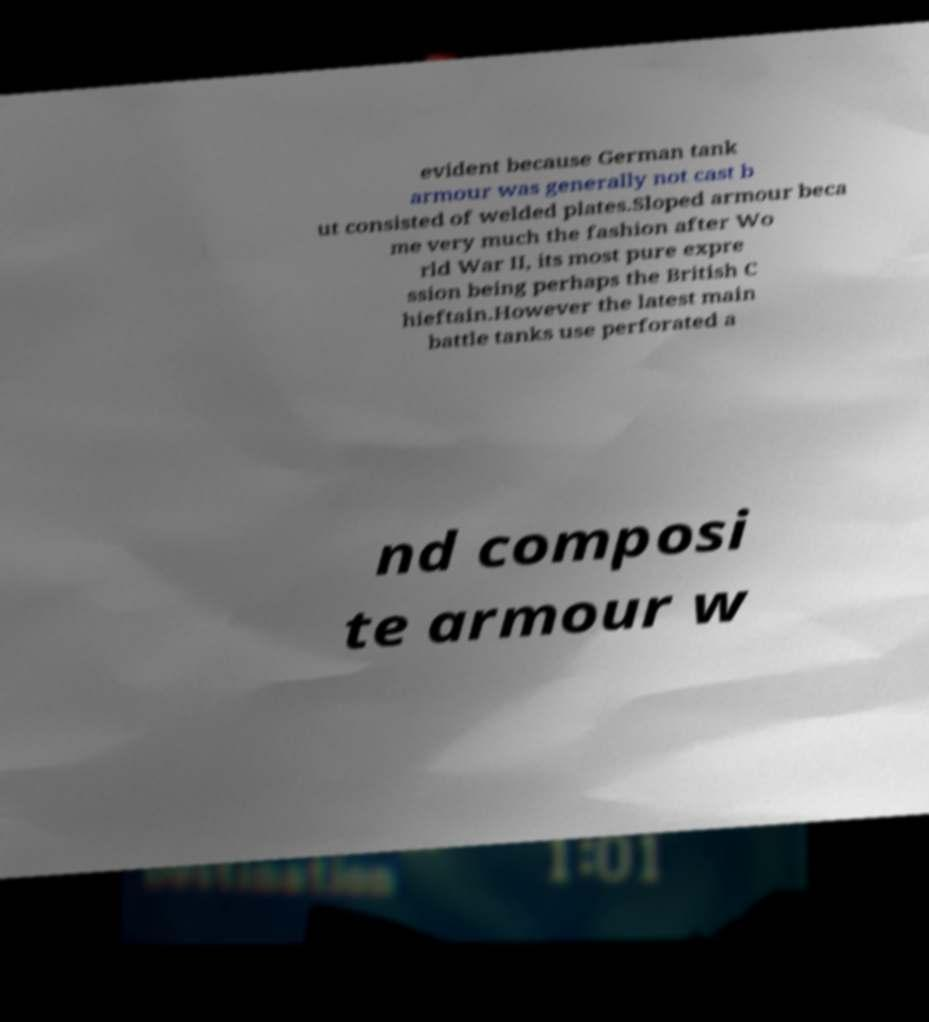For documentation purposes, I need the text within this image transcribed. Could you provide that? evident because German tank armour was generally not cast b ut consisted of welded plates.Sloped armour beca me very much the fashion after Wo rld War II, its most pure expre ssion being perhaps the British C hieftain.However the latest main battle tanks use perforated a nd composi te armour w 